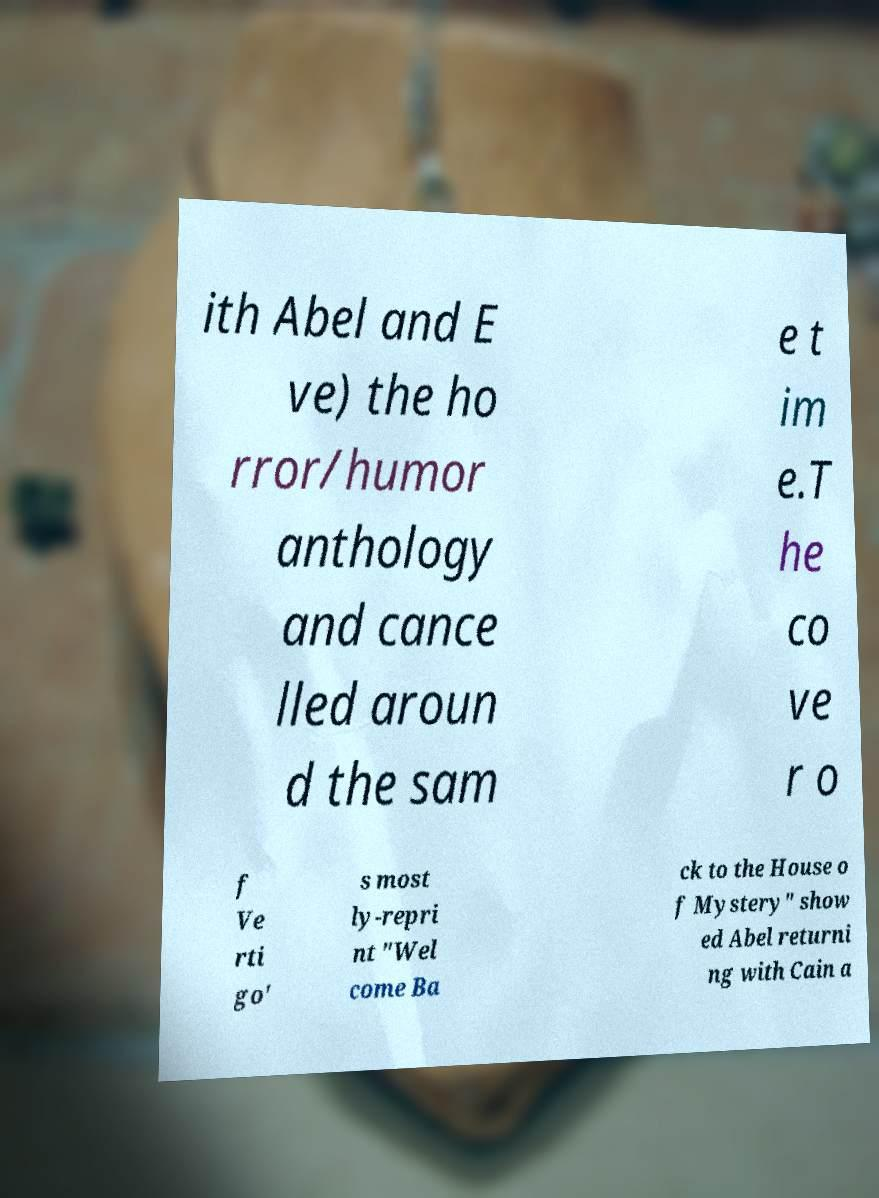Could you assist in decoding the text presented in this image and type it out clearly? ith Abel and E ve) the ho rror/humor anthology and cance lled aroun d the sam e t im e.T he co ve r o f Ve rti go' s most ly-repri nt "Wel come Ba ck to the House o f Mystery" show ed Abel returni ng with Cain a 